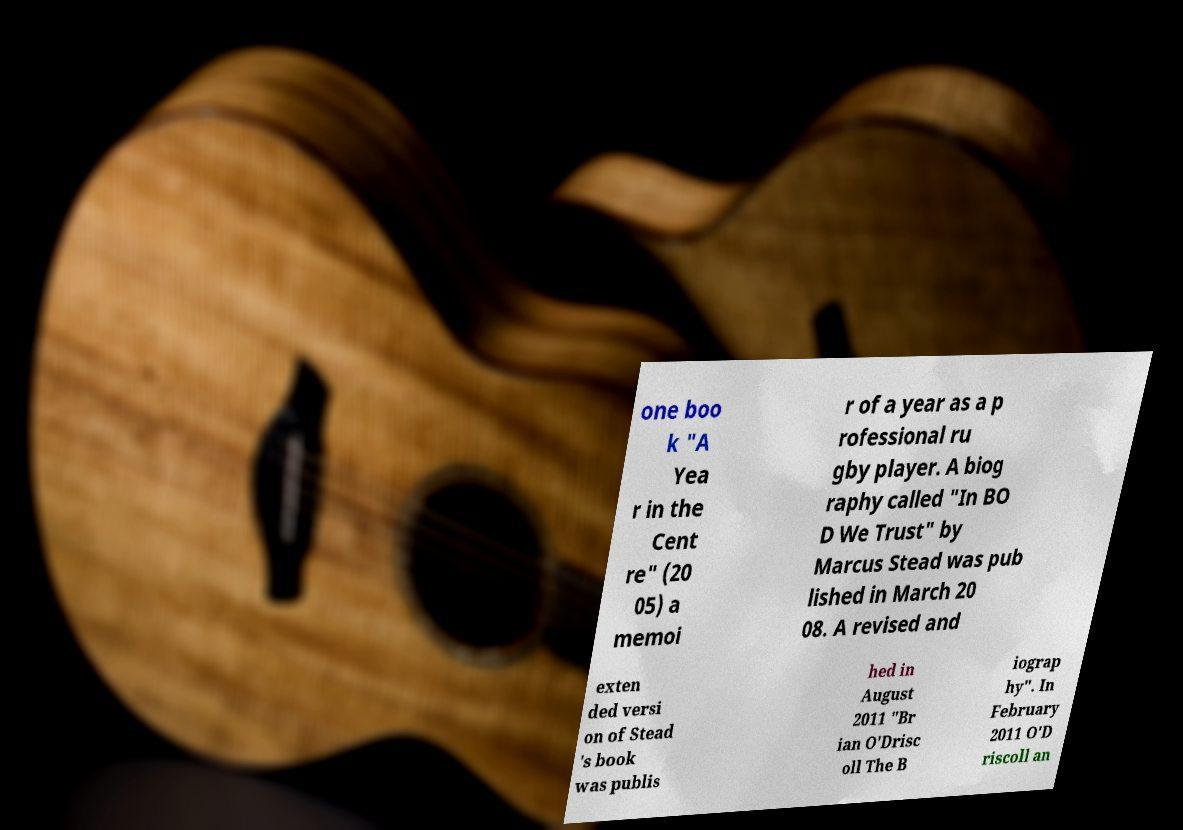Please read and relay the text visible in this image. What does it say? one boo k "A Yea r in the Cent re" (20 05) a memoi r of a year as a p rofessional ru gby player. A biog raphy called "In BO D We Trust" by Marcus Stead was pub lished in March 20 08. A revised and exten ded versi on of Stead 's book was publis hed in August 2011 "Br ian O'Drisc oll The B iograp hy". In February 2011 O'D riscoll an 